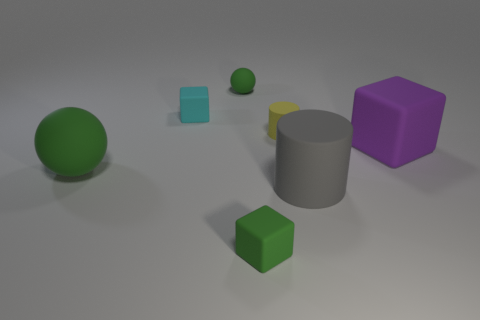What is the material of the block that is the same color as the tiny matte sphere?
Offer a terse response. Rubber. What number of objects are either purple blocks or big objects?
Keep it short and to the point. 3. Is there a large block that has the same color as the tiny ball?
Make the answer very short. No. How many green matte blocks are to the left of the block right of the tiny rubber cylinder?
Offer a very short reply. 1. Is the number of gray shiny cubes greater than the number of green rubber objects?
Your response must be concise. No. Is the number of small rubber cylinders that are to the left of the yellow rubber thing the same as the number of things?
Offer a very short reply. No. What number of green spheres are made of the same material as the small cyan block?
Your answer should be very brief. 2. Are there fewer purple blocks than purple metal things?
Keep it short and to the point. No. There is a object that is right of the large gray cylinder; is its color the same as the tiny rubber ball?
Offer a very short reply. No. There is a small green rubber thing that is behind the big gray object that is on the right side of the green rubber block; what number of matte balls are on the left side of it?
Provide a succinct answer. 1. 